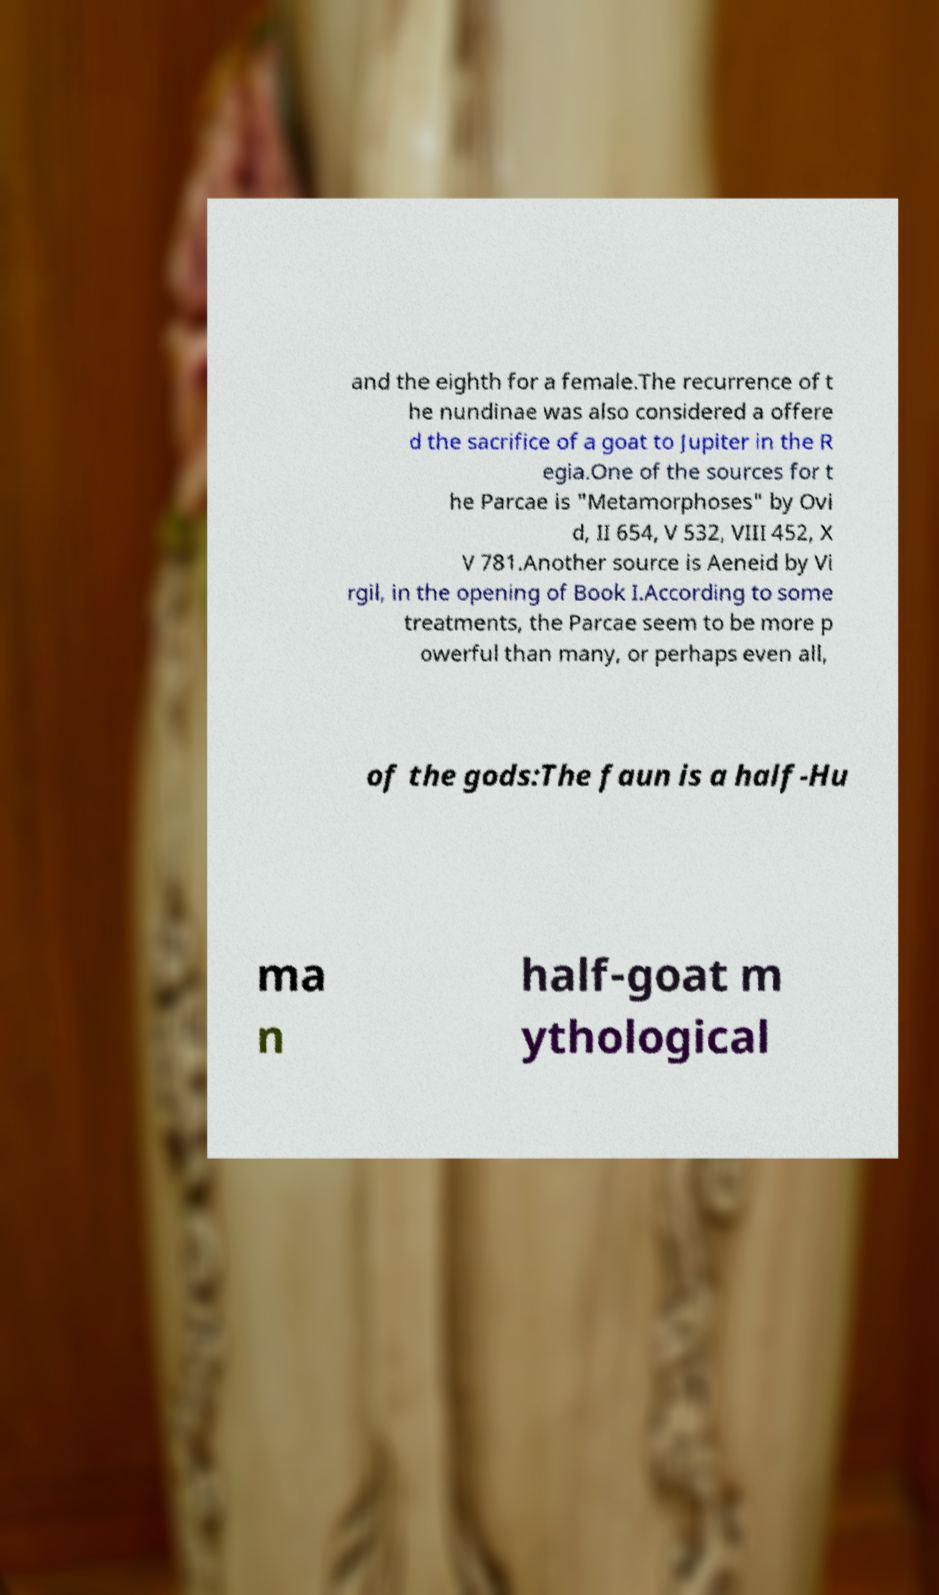Could you assist in decoding the text presented in this image and type it out clearly? and the eighth for a female.The recurrence of t he nundinae was also considered a offere d the sacrifice of a goat to Jupiter in the R egia.One of the sources for t he Parcae is "Metamorphoses" by Ovi d, II 654, V 532, VIII 452, X V 781.Another source is Aeneid by Vi rgil, in the opening of Book I.According to some treatments, the Parcae seem to be more p owerful than many, or perhaps even all, of the gods:The faun is a half-Hu ma n half-goat m ythological 